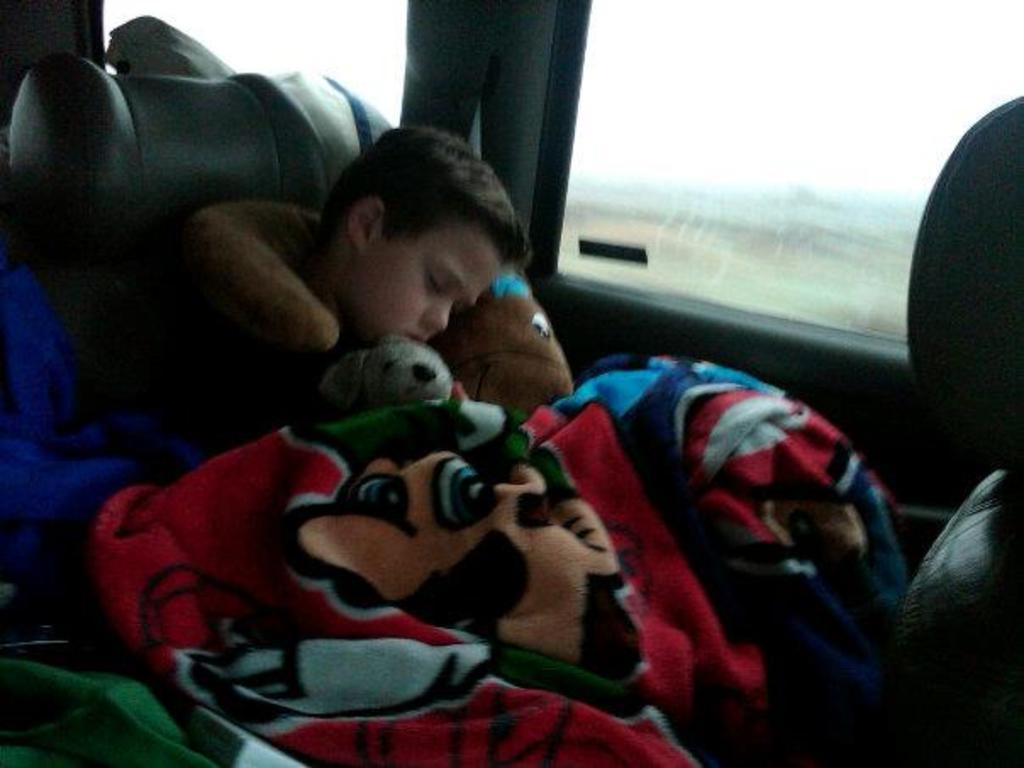What is the main subject of the picture? The main subject of the picture is a kid. What is the kid doing in the picture? The kid is sitting and sleeping in the picture. What other objects can be seen in the picture? There is a doll and a blanket in the picture. How is the blanket related to the kid? The blanket is on the kid in the picture. What is the location of the glass window in the picture? The glass window is beside the kid in the picture. How many dogs can be seen playing in the bedroom in the image? There are no dogs or bedrooms present in the image; it features a kid sitting and sleeping with a doll and a blanket. 